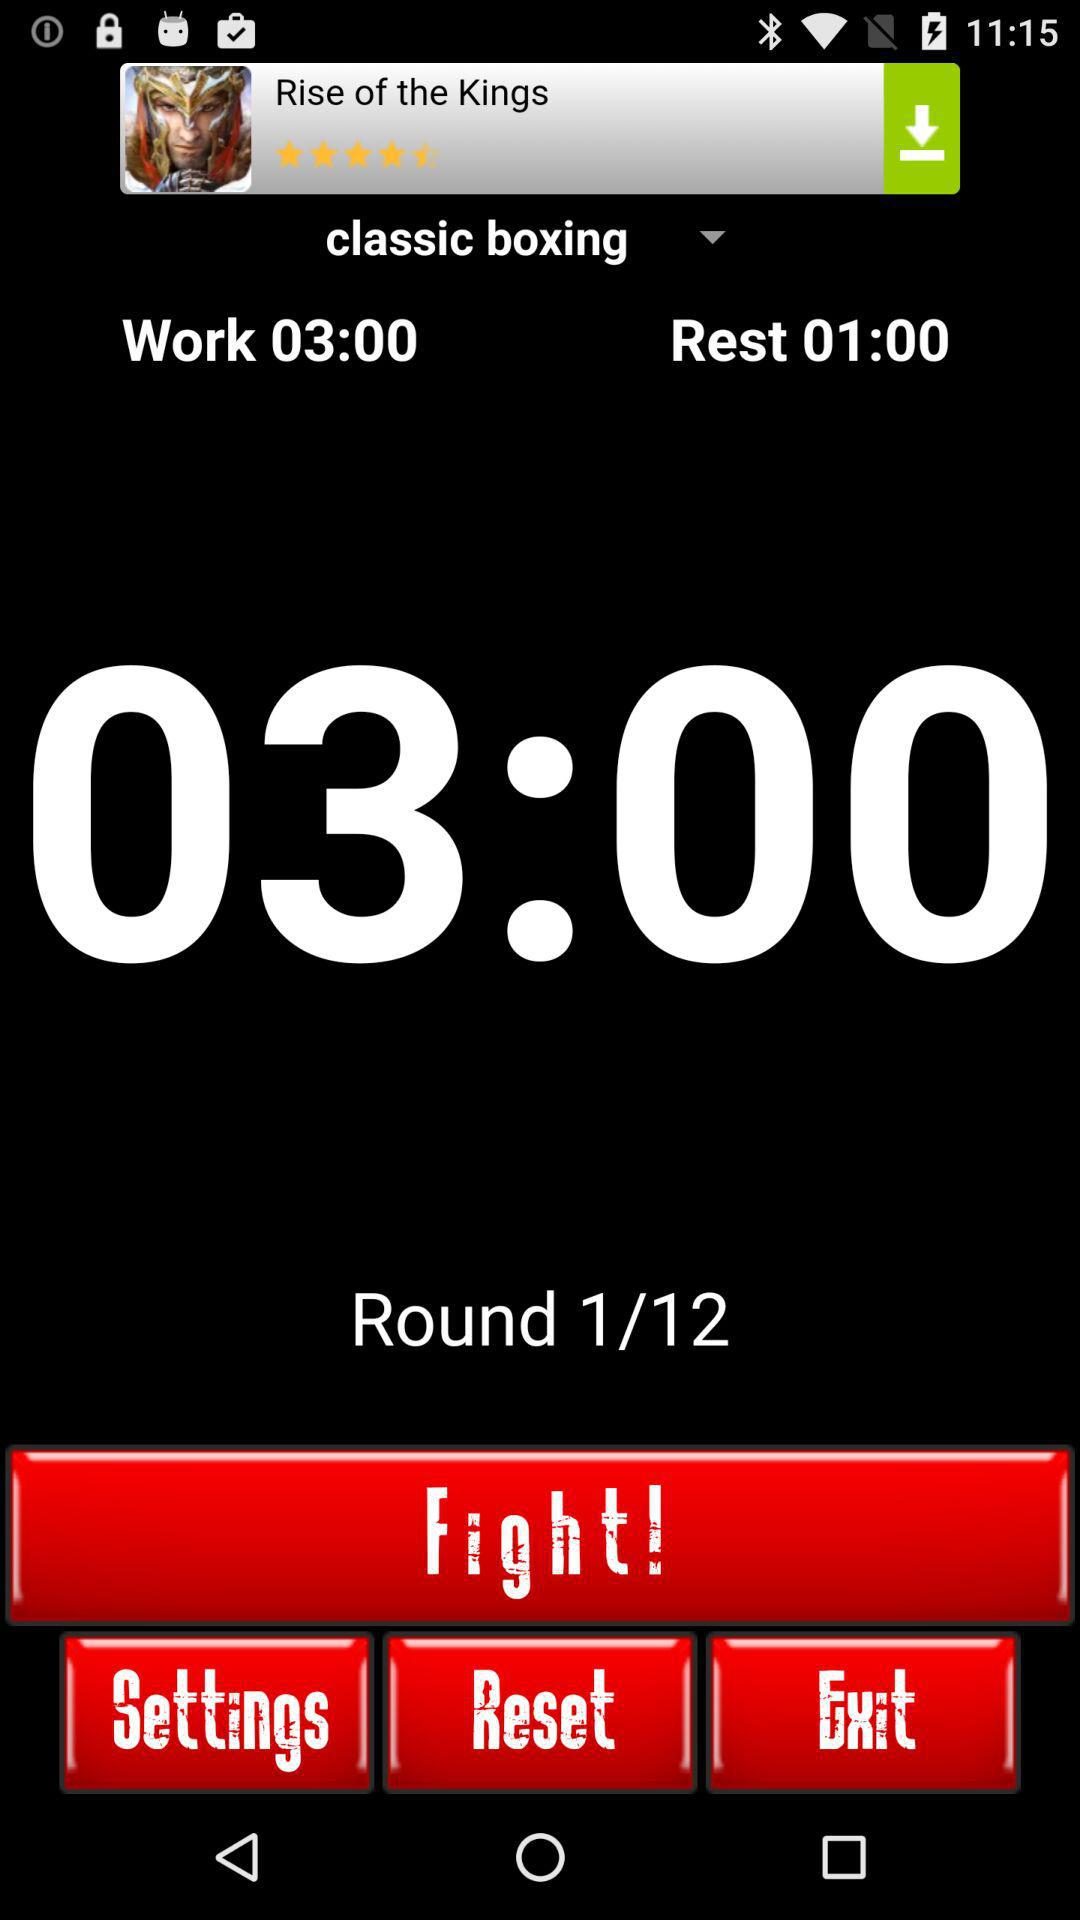How many rounds have been completed out of 12? The number of rounds that have been completed is 1. 